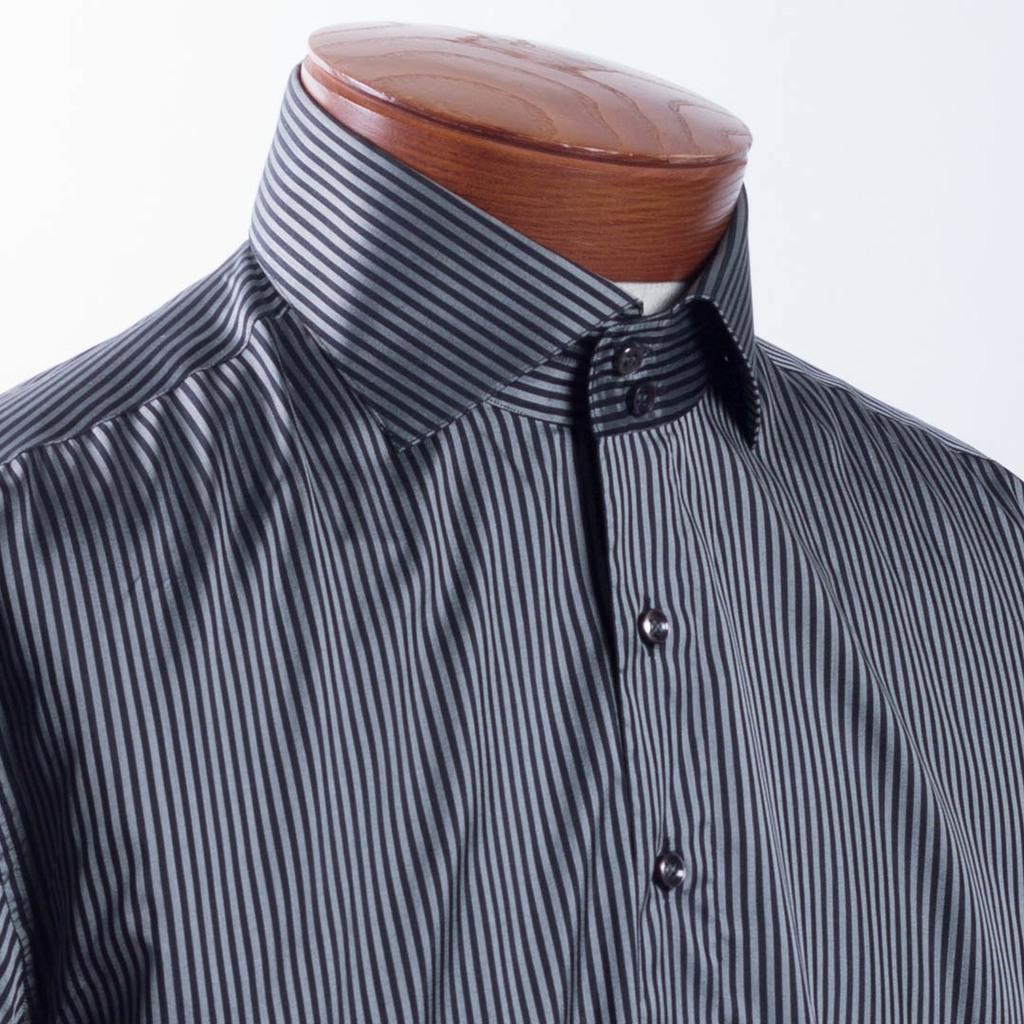What is the main subject of the image? There is a mannequin in the image. What is unusual about the mannequin? The mannequin does not have a head. What type of clothing is the mannequin wearing? The mannequin is wearing a shirt. What type of earth can be seen in the image? There is no earth visible in the image; it features a mannequin without a head wearing a shirt. What direction is the train traveling in the image? There is no train present in the image. 